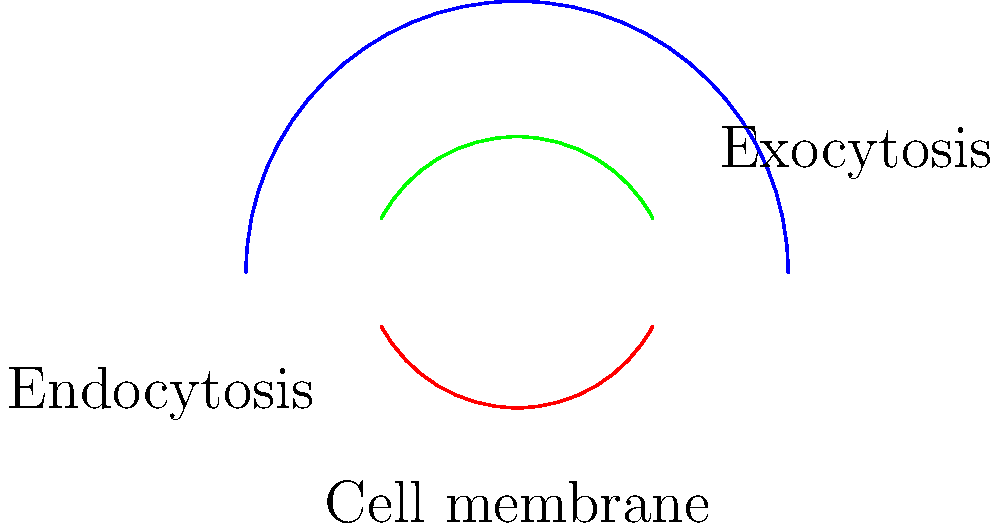In the context of cell membrane topology during endocytosis and exocytosis, which mathematical concept best describes the continuous deformation of the membrane without tearing or gluing? How does this concept relate to the preservation of membrane integrity in medical conditions involving abnormal vesicle trafficking? To answer this question, let's break it down step-by-step:

1. Topology in cell membranes:
   The cell membrane undergoes continuous deformations during endocytosis (inward budding) and exocytosis (outward fusion). These processes involve bending and reshaping of the membrane without breaking or joining separate parts.

2. Mathematical concept:
   The concept that best describes this continuous deformation is homeomorphism. In topology, two objects are considered homeomorphic if one can be continuously deformed into the other without cutting or gluing.

3. Membrane deformation during endocytosis:
   - The membrane invaginates, forming a pocket.
   - The pocket deepens and eventually pinches off to form a vesicle.
   - Throughout this process, the membrane remains continuous and unbroken.

4. Membrane deformation during exocytosis:
   - A vesicle approaches the cell membrane from the interior.
   - The vesicle membrane fuses with the cell membrane.
   - The contents are released, and the membrane becomes continuous with the cell membrane.

5. Preservation of membrane integrity:
   The homeomorphic nature of these deformations ensures that the membrane's fundamental structure and function are maintained. This is crucial for:
   - Maintaining cell compartmentalization
   - Preserving the selective permeability of the membrane
   - Ensuring proper cellular communication and transport

6. Relevance to medical conditions:
   In diseases involving abnormal vesicle trafficking (e.g., lysosomal storage disorders, certain neurodegenerative diseases), the homeomorphic properties of membrane deformations may be disrupted. This can lead to:
   - Accumulation of cellular waste
   - Impaired cellular communication
   - Disruption of normal cellular processes

Understanding the topological nature of membrane deformations is crucial for developing treatments that target these conditions without compromising overall membrane integrity.
Answer: Homeomorphism 